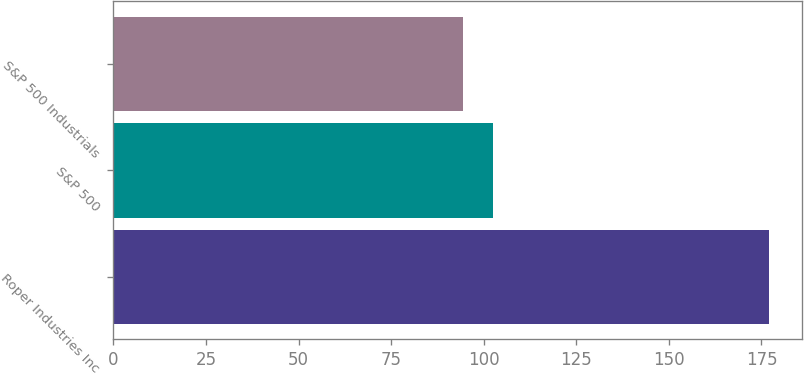<chart> <loc_0><loc_0><loc_500><loc_500><bar_chart><fcel>Roper Industries Inc<fcel>S&P 500<fcel>S&P 500 Industrials<nl><fcel>177<fcel>102.61<fcel>94.35<nl></chart> 